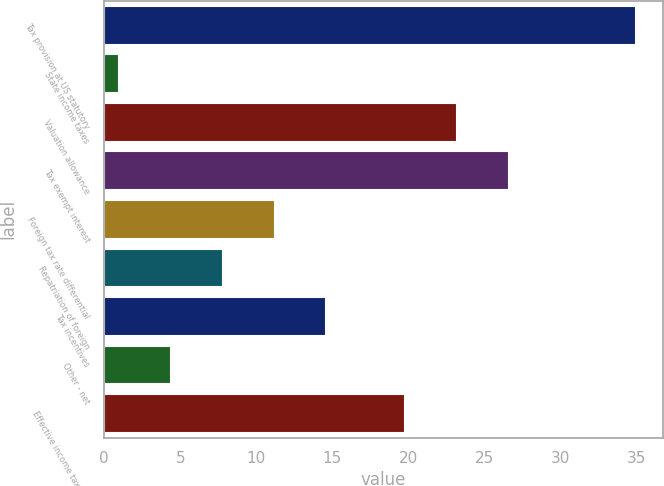Convert chart to OTSL. <chart><loc_0><loc_0><loc_500><loc_500><bar_chart><fcel>Tax provision at US statutory<fcel>State income taxes<fcel>Valuation allowance<fcel>Tax exempt interest<fcel>Foreign tax rate differential<fcel>Repatriation of foreign<fcel>Tax incentives<fcel>Other - net<fcel>Effective income tax rate<nl><fcel>35<fcel>1<fcel>23.2<fcel>26.6<fcel>11.2<fcel>7.8<fcel>14.6<fcel>4.4<fcel>19.8<nl></chart> 